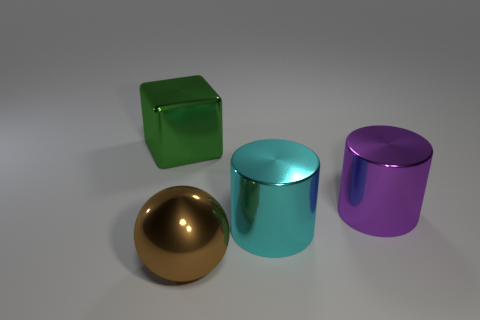Add 2 big purple objects. How many objects exist? 6 Subtract all spheres. How many objects are left? 3 Add 3 brown metallic objects. How many brown metallic objects are left? 4 Add 2 brown shiny spheres. How many brown shiny spheres exist? 3 Subtract 0 yellow cubes. How many objects are left? 4 Subtract all small yellow spheres. Subtract all cyan metallic objects. How many objects are left? 3 